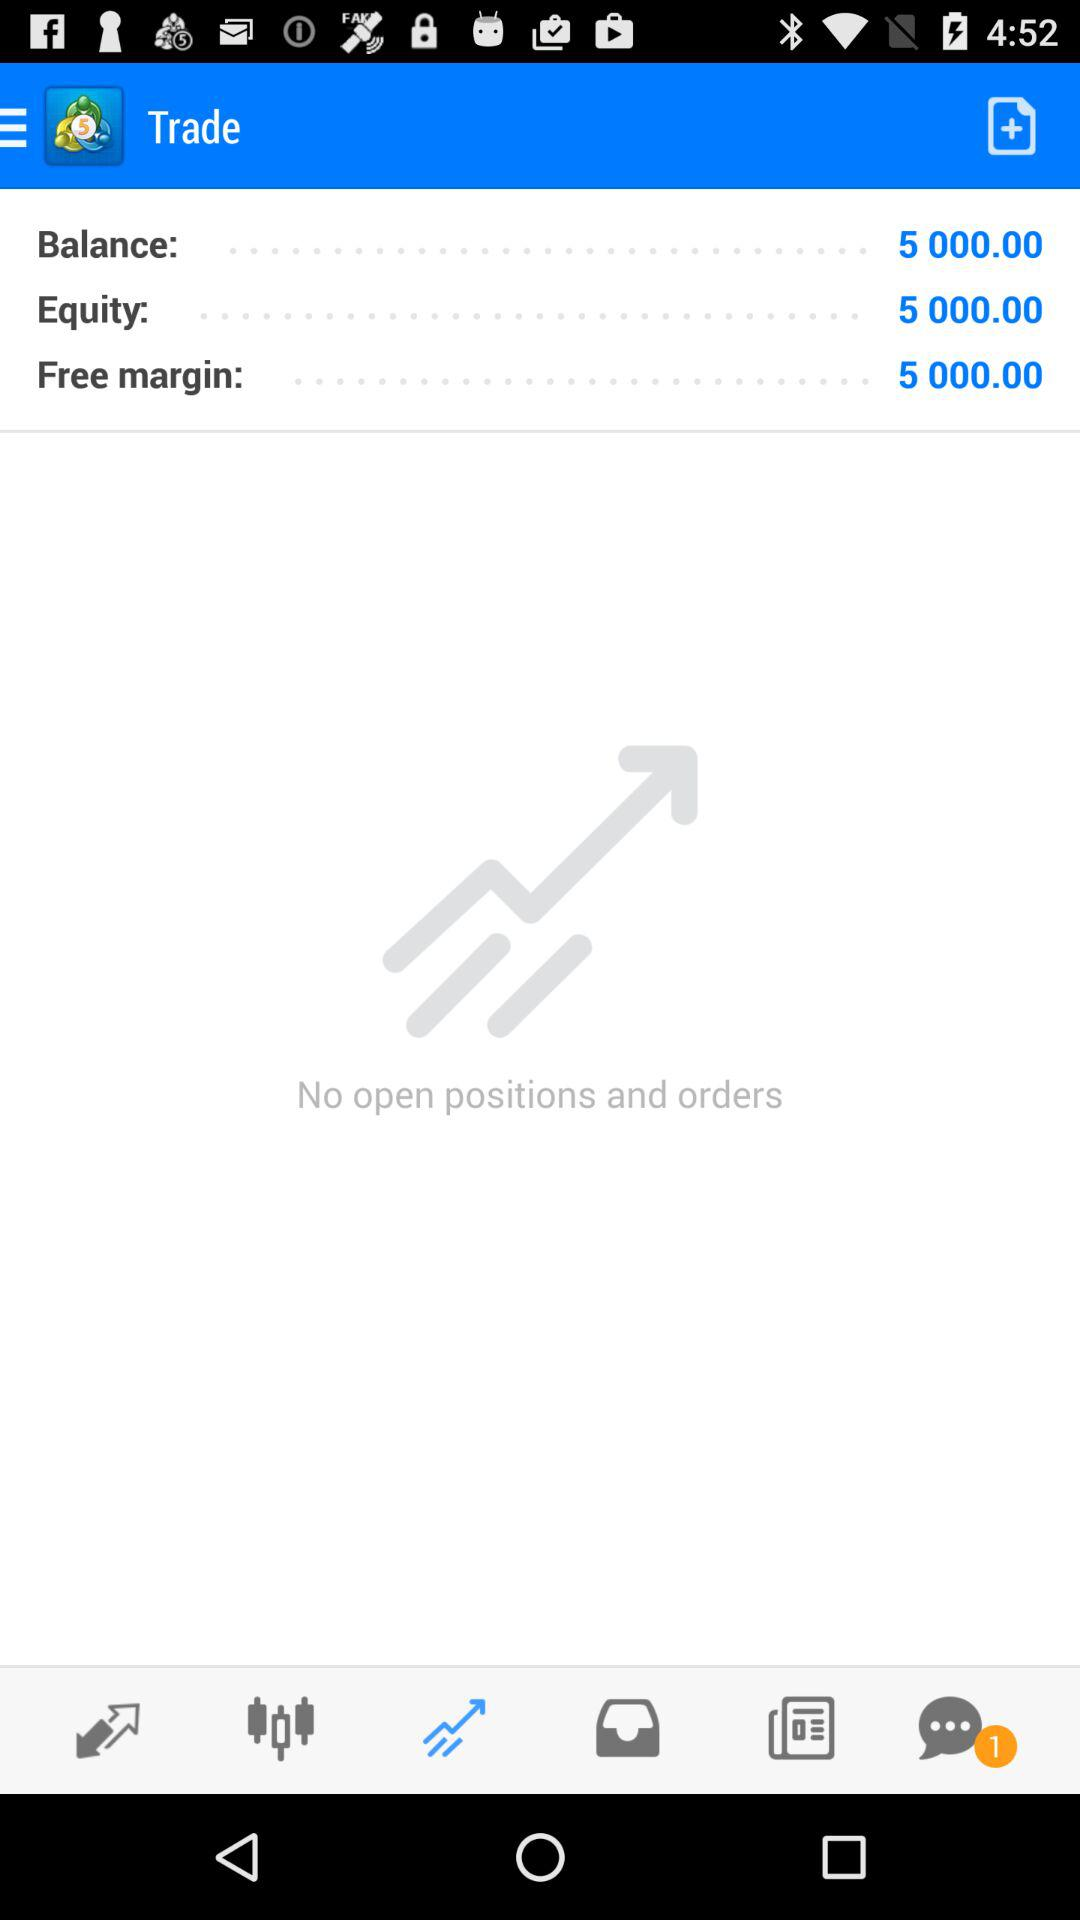How much is the balance in "Trade"? The balance is 5,000. 